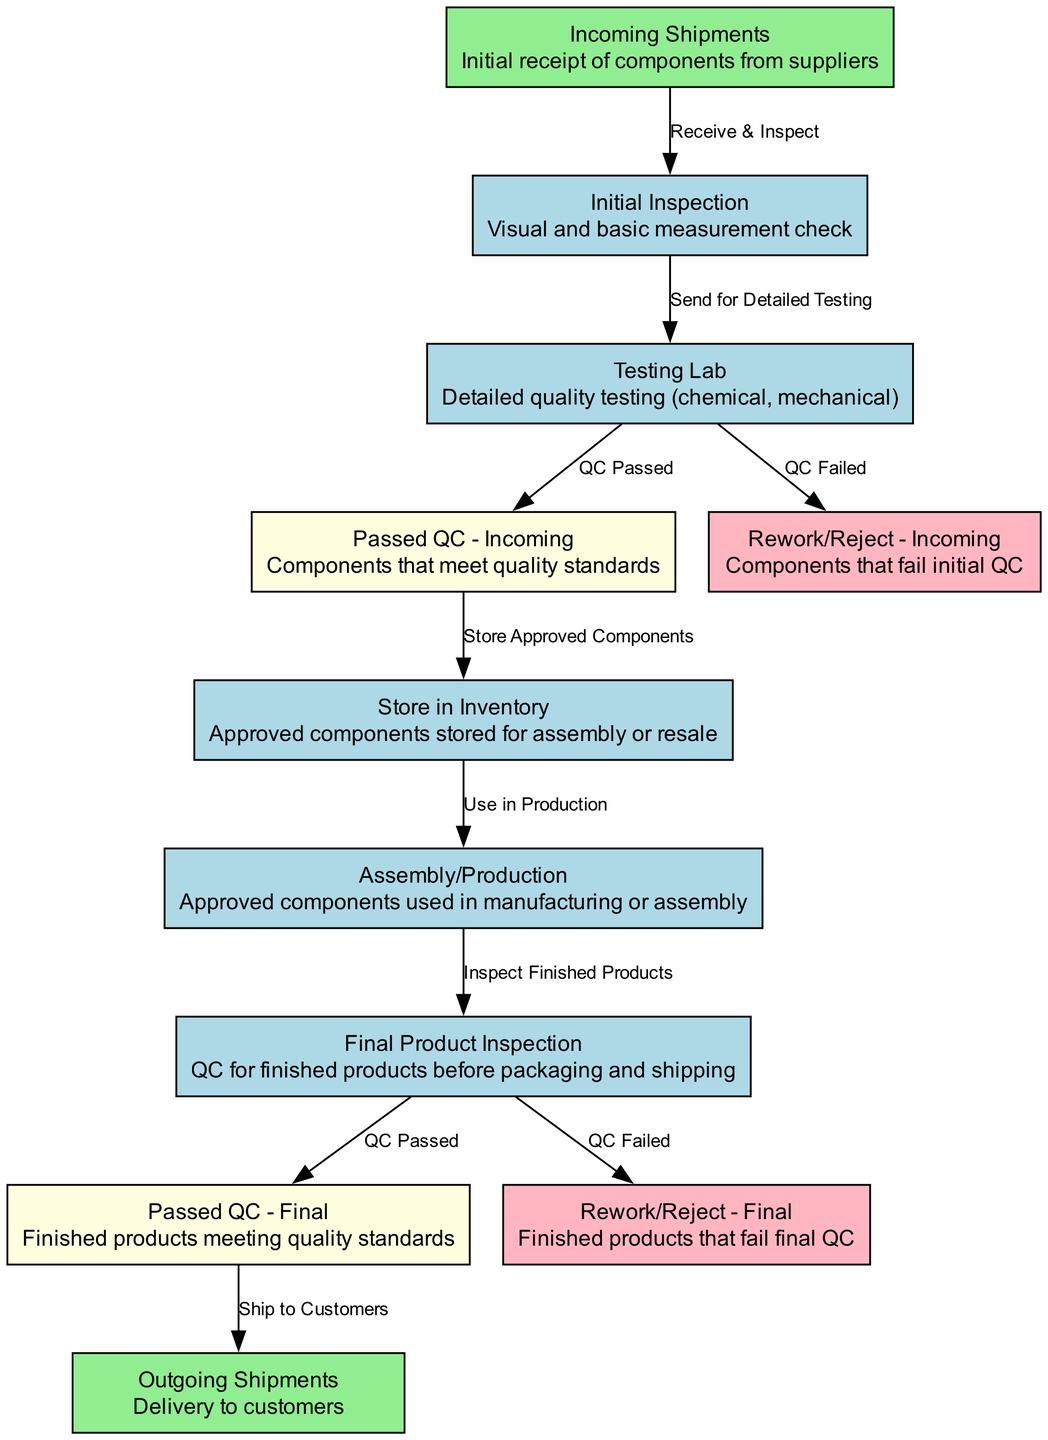What is the first node in the flowchart? The first node, typically indicating the starting point of the flowchart, is "Incoming Shipments," which represents the initial receipt of components from suppliers.
Answer: Incoming Shipments How many total nodes are there in the diagram? By counting the defined nodes, we see there are 10 nodes in total that correspond to various steps in the quality control process.
Answer: 10 What label describes the process after "Initial Inspection"? The process that follows "Initial Inspection" is labeled "Testing Lab," indicating that components are sent for detailed testing after the initial check.
Answer: Testing Lab Which nodes represent components that fail quality control? The nodes that indicate the failure of quality control are "Rework/Reject - Incoming" and "Rework/Reject - Final," highlighting components that do not meet quality standards at different stages.
Answer: Rework/Reject - Incoming, Rework/Reject - Final What is the status of components that pass the initial quality control? Components that successfully meet the quality standards after inspections are labeled "Passed QC - Incoming," showing they are accepted for further processing.
Answer: Passed QC - Incoming What happens to approved components after they are stored in inventory? Once components are stored in inventory, they progress to the node labeled "Assembly/Production," where they are utilized in manufacturing or assembly processes.
Answer: Assembly/Production What is the outcome of finished products after passing final quality control? Finished products that pass final quality control are categorized under the node "Passed QC - Final," which indicates they are deemed acceptable for shipping to customers.
Answer: Passed QC - Final What are the endpoints in the flowchart? The endpoints of this flowchart, which signify the final stages of the process, are "Outgoing Shipments," where the products are delivered to customers, and "Rework/Reject - Final," indicating rework or rejection of products that did not pass the final inspection.
Answer: Outgoing Shipments, Rework/Reject - Final Which edges represent the transition of components that did not meet quality standards? The edges that show the transition of components failing quality control are "QC Failed" from both the "Testing Lab" and "Final Product Inspection," leading to their respective rework/reject nodes.
Answer: QC Failed 